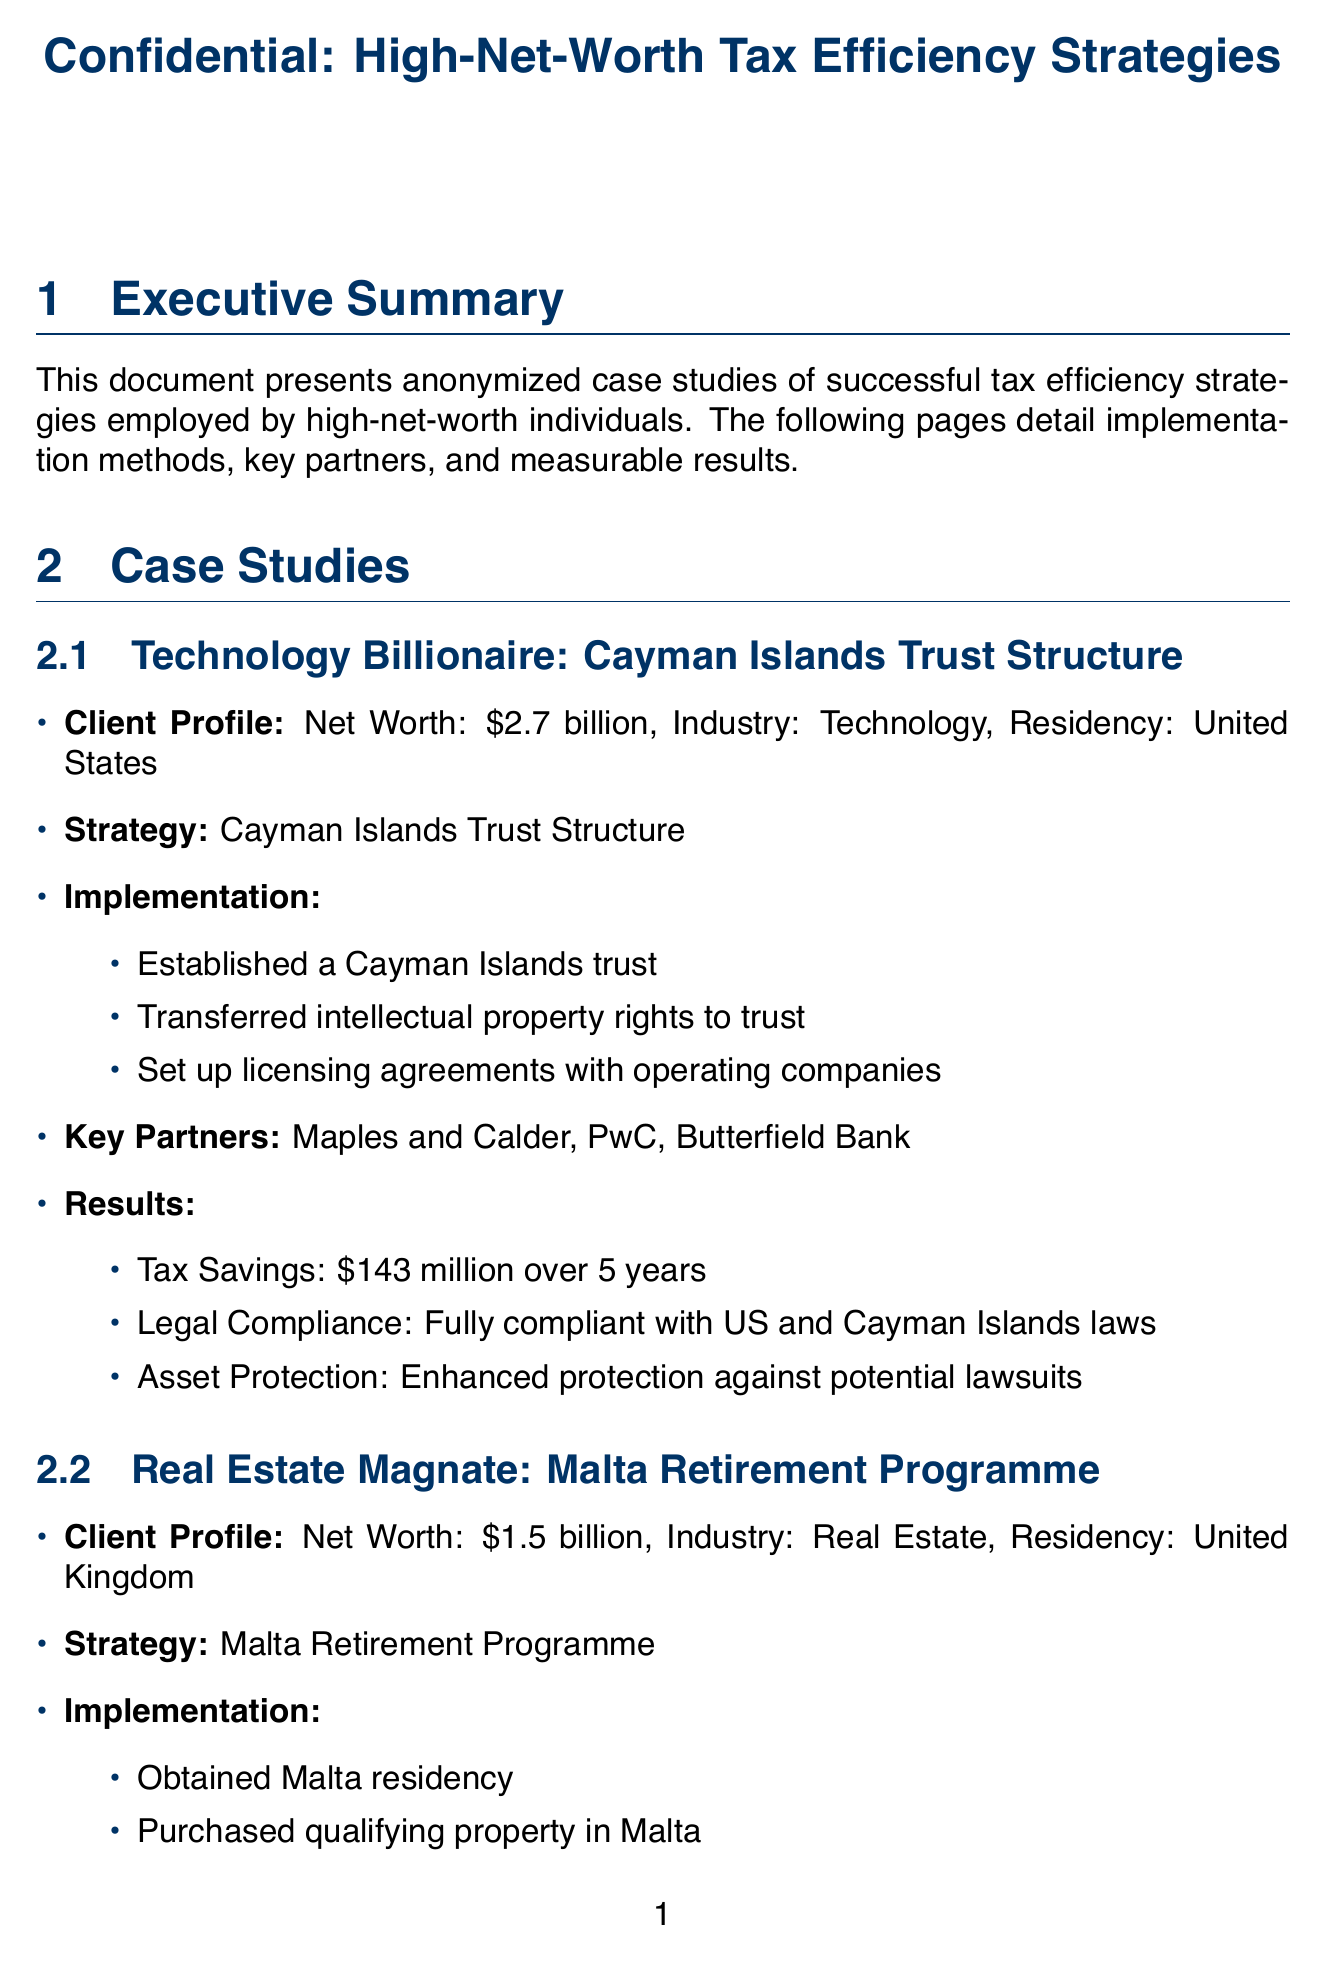What is the tax savings for the Technology client? The tax savings for the Technology client is derived from the Cayman Islands Trust Structure strategy, which is $143 million over 5 years.
Answer: $143 million over 5 years What industry does the client with a net worth of $1.8 billion operate in? The client with a net worth of $1.8 billion operates in the Pharmaceuticals industry.
Answer: Pharmaceuticals What is the effective tax rate reduced to for the Real Estate client? The effective tax rate for the Real Estate client is reduced from 45% to 15% as outlined in the Malta Retirement Programme.
Answer: 15% Who is the law firm partner for the Swiss Principal Company Structure? The law firm partner associated with the Swiss Principal Company Structure is Bär & Karrer.
Answer: Bär & Karrer What is a key consideration mentioned in the document regarding offshore structures? One key consideration mentioned is the importance of substance in offshore structures.
Answer: Importance of substance in offshore structures How many years of tax savings are reported for the E-commerce client? The tax savings for the E-commerce client are reported over a period of 3 years.
Answer: 3 years What strategic advantage is noted for the client using the Singapore Global Trading Programme? The strategic advantage noted for the client using the Singapore Global Trading Programme is enhanced access to Asian markets.
Answer: Enhanced access to Asian markets What is one emerging trend highlighted in the document? One emerging trend highlighted in the document is the increased focus on economic substance requirements.
Answer: Increased focus on economic substance requirements 